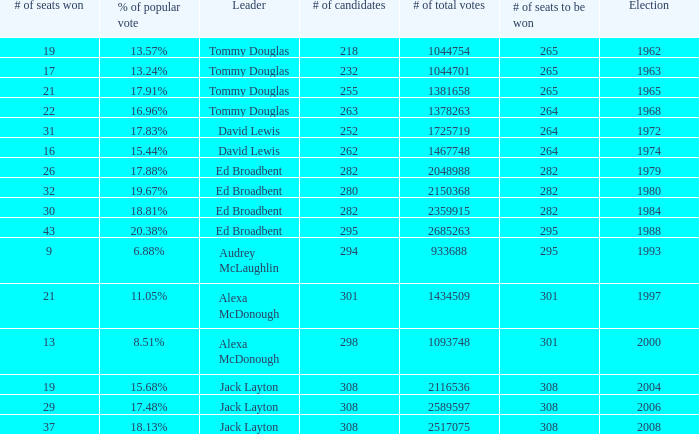Name the number of candidates for # of seats won being 43 295.0. 